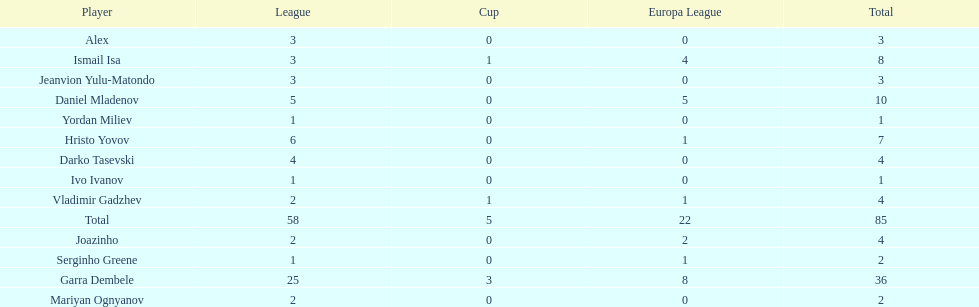Who had the most goal scores? Garra Dembele. 